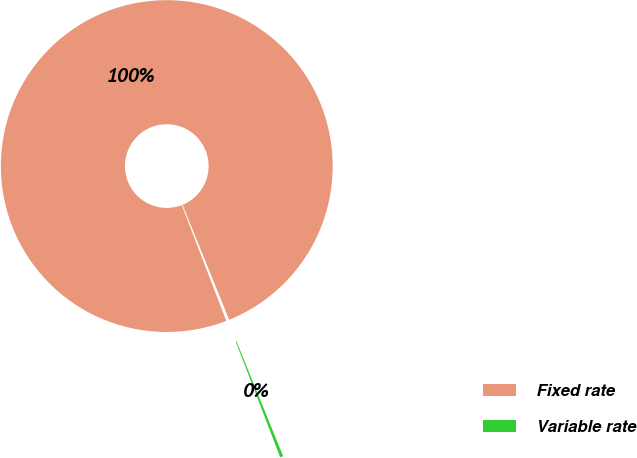Convert chart. <chart><loc_0><loc_0><loc_500><loc_500><pie_chart><fcel>Fixed rate<fcel>Variable rate<nl><fcel>99.7%<fcel>0.3%<nl></chart> 